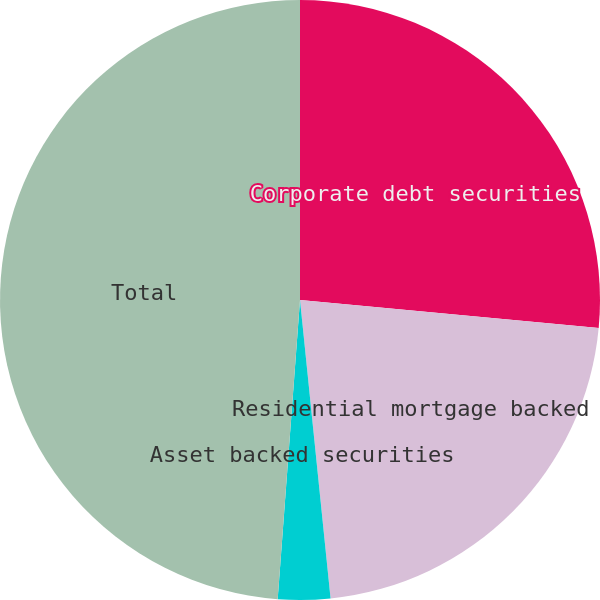Convert chart to OTSL. <chart><loc_0><loc_0><loc_500><loc_500><pie_chart><fcel>Corporate debt securities<fcel>Residential mortgage backed<fcel>Asset backed securities<fcel>Total<nl><fcel>26.49%<fcel>21.89%<fcel>2.81%<fcel>48.82%<nl></chart> 